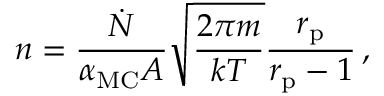Convert formula to latex. <formula><loc_0><loc_0><loc_500><loc_500>n = \frac { \dot { N } } { \alpha _ { M C } A } \sqrt { \frac { 2 \pi m } { k T } } \frac { r _ { p } } { r _ { p } - 1 } \, ,</formula> 